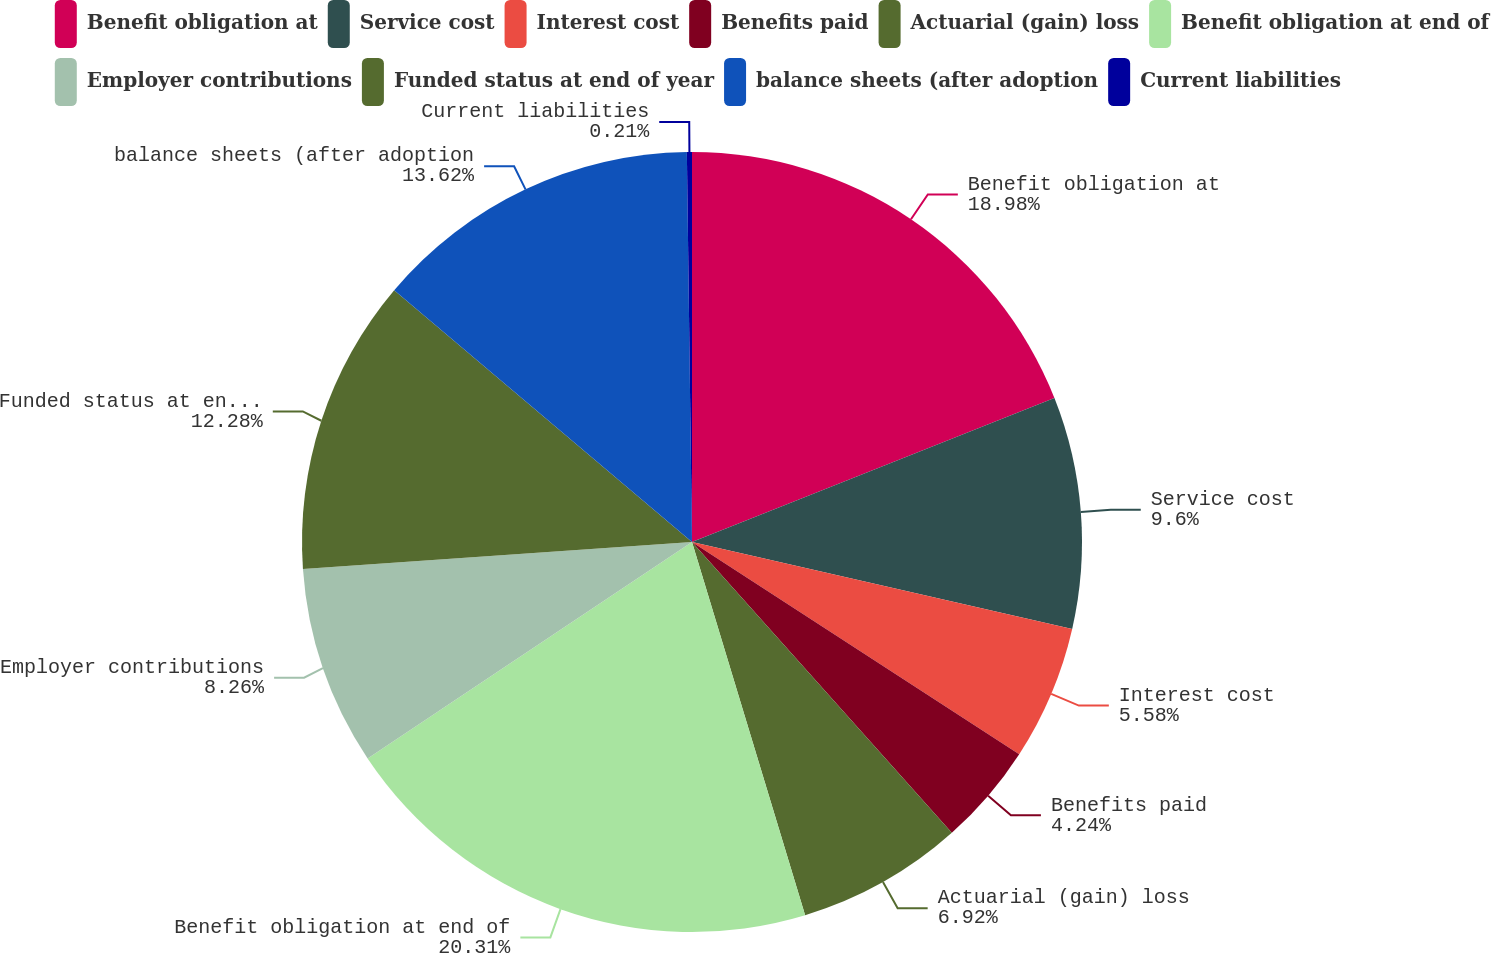Convert chart. <chart><loc_0><loc_0><loc_500><loc_500><pie_chart><fcel>Benefit obligation at<fcel>Service cost<fcel>Interest cost<fcel>Benefits paid<fcel>Actuarial (gain) loss<fcel>Benefit obligation at end of<fcel>Employer contributions<fcel>Funded status at end of year<fcel>balance sheets (after adoption<fcel>Current liabilities<nl><fcel>18.98%<fcel>9.6%<fcel>5.58%<fcel>4.24%<fcel>6.92%<fcel>20.32%<fcel>8.26%<fcel>12.28%<fcel>13.62%<fcel>0.21%<nl></chart> 